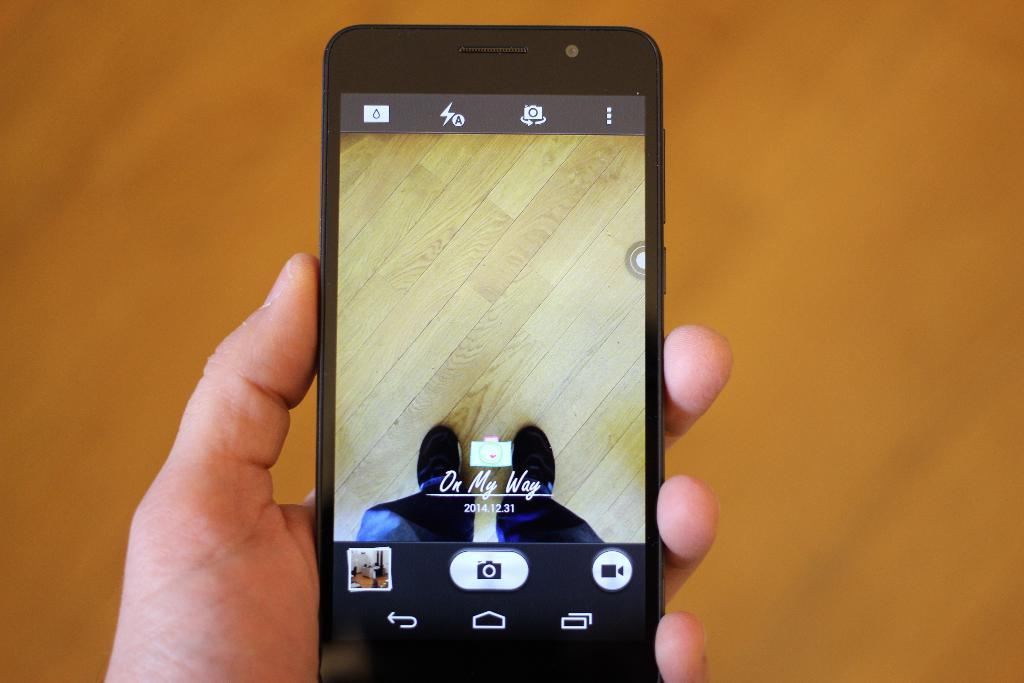<image>
Write a terse but informative summary of the picture. A cellphone screen shows the image of a wood floor and a pair of shoed feet with the caption "On My Way 2014.12.31." 